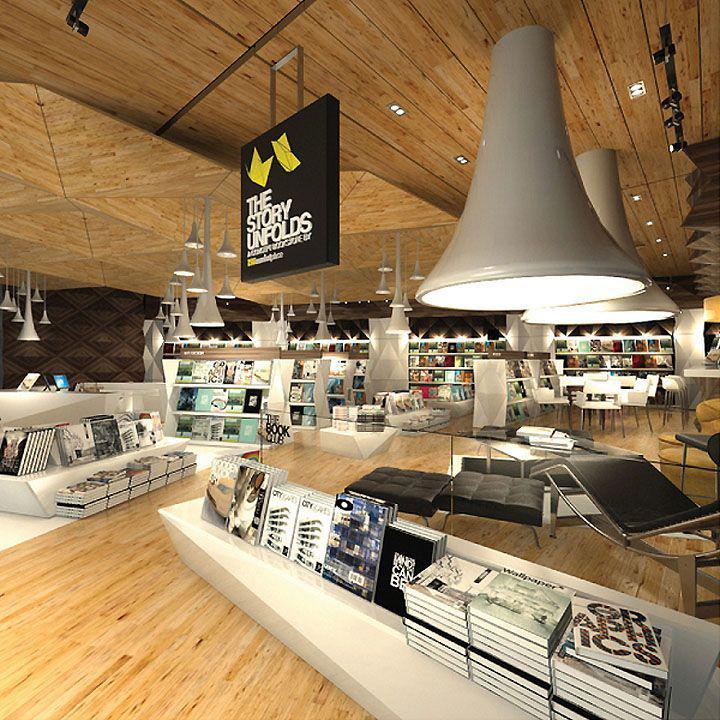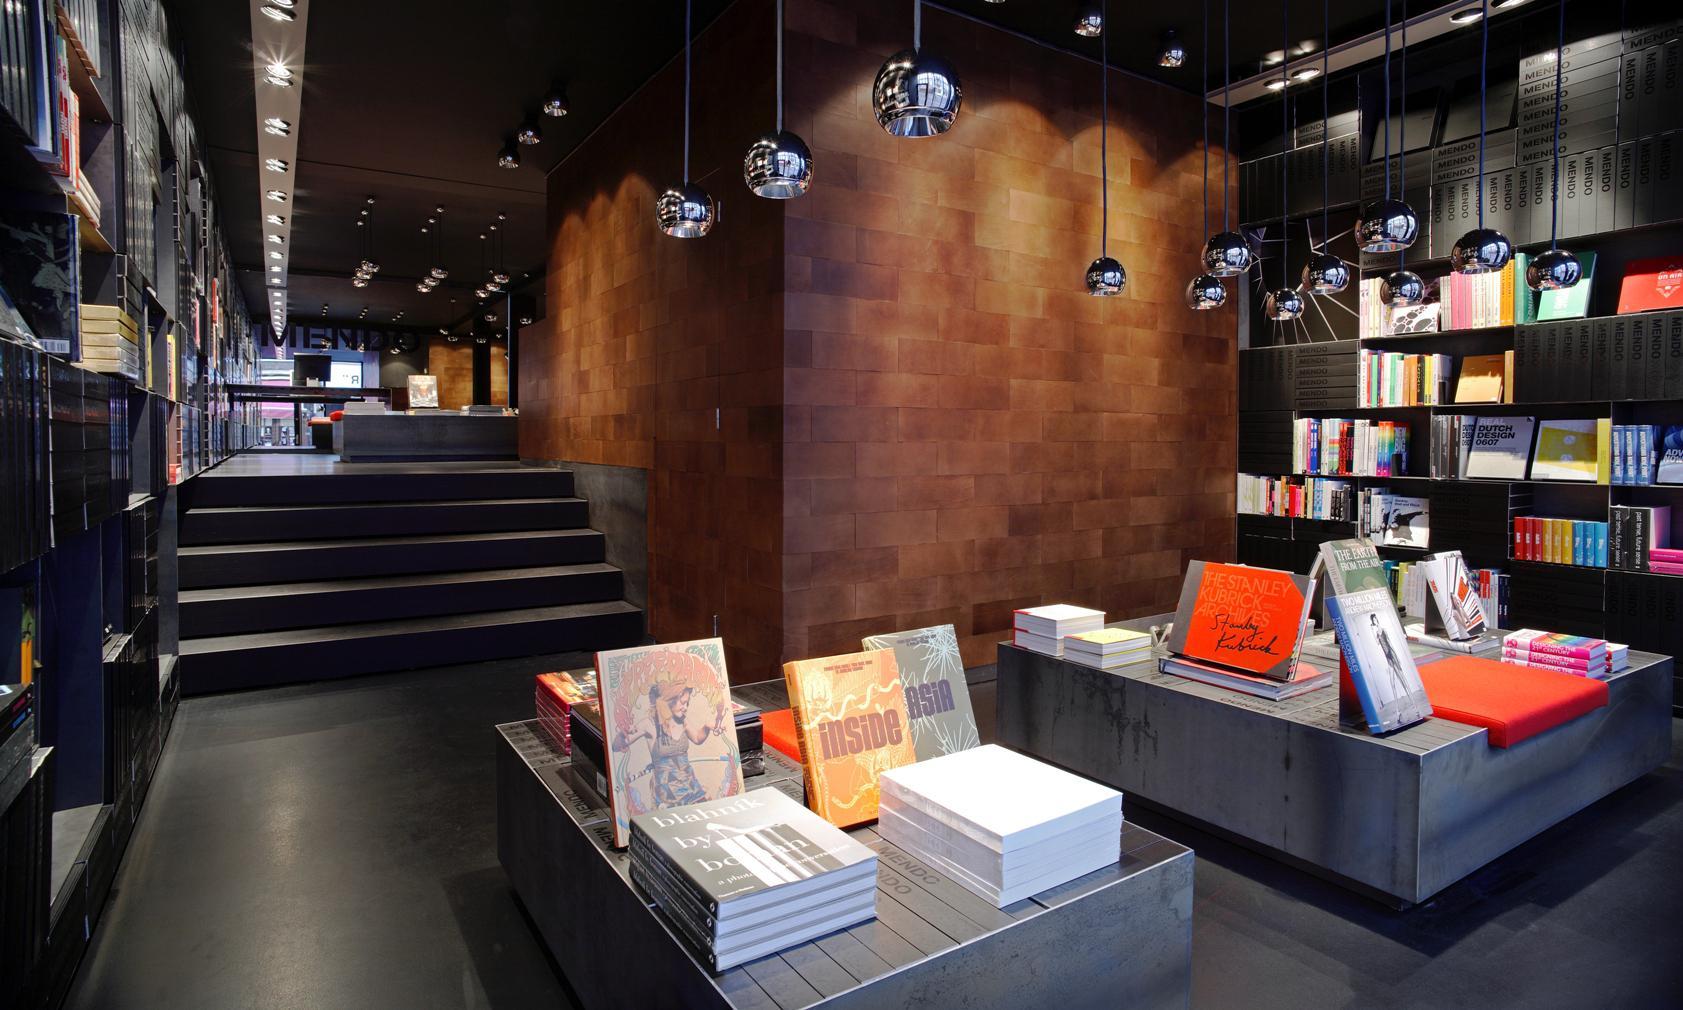The first image is the image on the left, the second image is the image on the right. Assess this claim about the two images: "There is seating visible in at least one of the images.". Correct or not? Answer yes or no. Yes. The first image is the image on the left, the second image is the image on the right. For the images displayed, is the sentence "Atleast one building has a wooden floor." factually correct? Answer yes or no. Yes. 